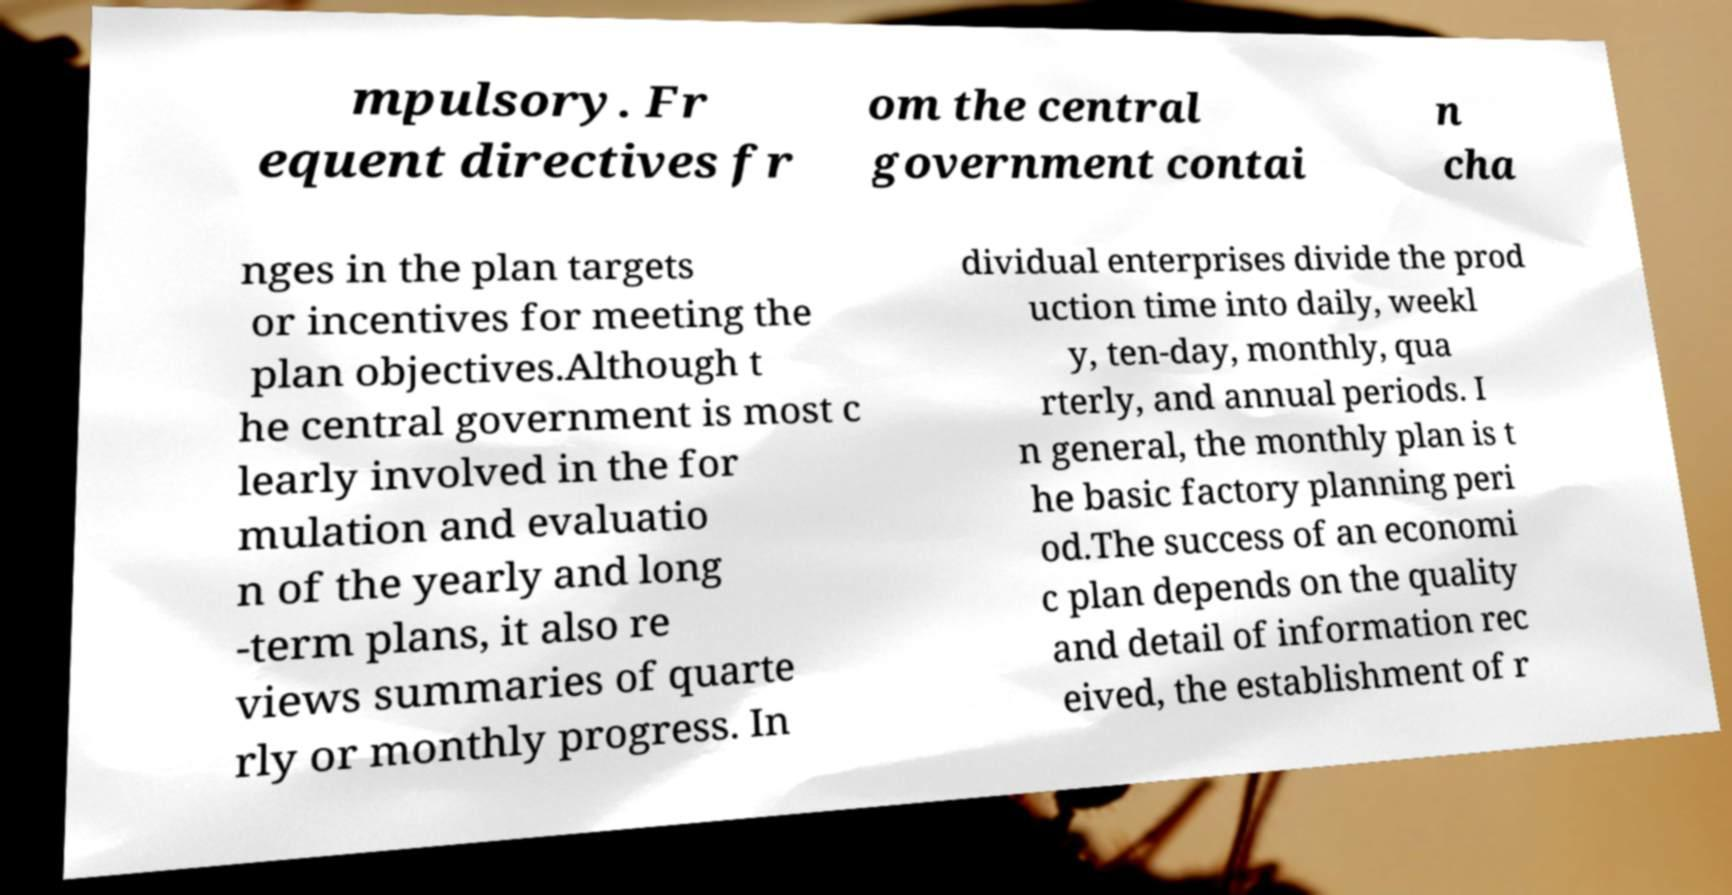Can you accurately transcribe the text from the provided image for me? mpulsory. Fr equent directives fr om the central government contai n cha nges in the plan targets or incentives for meeting the plan objectives.Although t he central government is most c learly involved in the for mulation and evaluatio n of the yearly and long -term plans, it also re views summaries of quarte rly or monthly progress. In dividual enterprises divide the prod uction time into daily, weekl y, ten-day, monthly, qua rterly, and annual periods. I n general, the monthly plan is t he basic factory planning peri od.The success of an economi c plan depends on the quality and detail of information rec eived, the establishment of r 